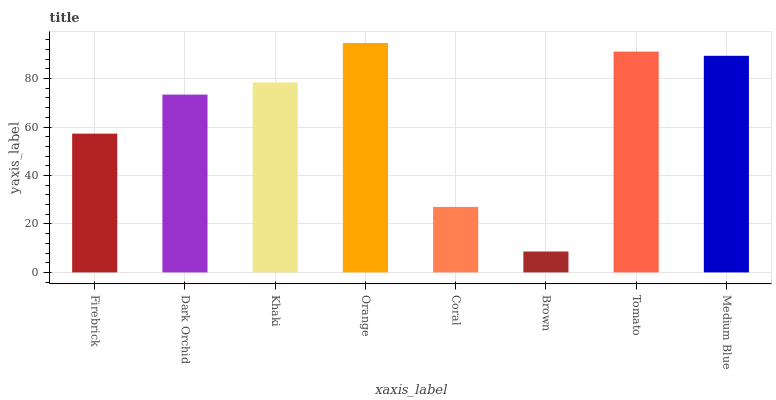Is Brown the minimum?
Answer yes or no. Yes. Is Orange the maximum?
Answer yes or no. Yes. Is Dark Orchid the minimum?
Answer yes or no. No. Is Dark Orchid the maximum?
Answer yes or no. No. Is Dark Orchid greater than Firebrick?
Answer yes or no. Yes. Is Firebrick less than Dark Orchid?
Answer yes or no. Yes. Is Firebrick greater than Dark Orchid?
Answer yes or no. No. Is Dark Orchid less than Firebrick?
Answer yes or no. No. Is Khaki the high median?
Answer yes or no. Yes. Is Dark Orchid the low median?
Answer yes or no. Yes. Is Orange the high median?
Answer yes or no. No. Is Firebrick the low median?
Answer yes or no. No. 